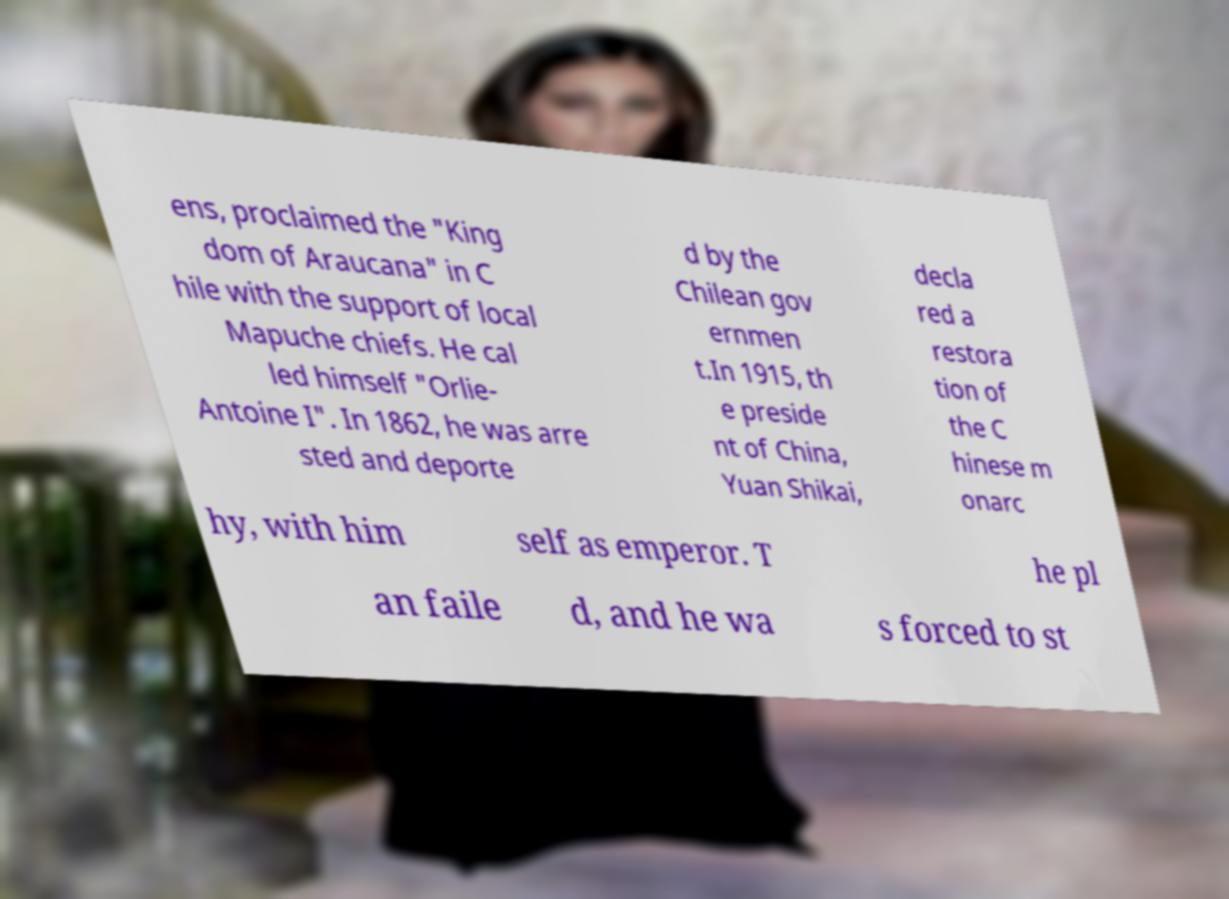Please identify and transcribe the text found in this image. ens, proclaimed the "King dom of Araucana" in C hile with the support of local Mapuche chiefs. He cal led himself "Orlie- Antoine I". In 1862, he was arre sted and deporte d by the Chilean gov ernmen t.In 1915, th e preside nt of China, Yuan Shikai, decla red a restora tion of the C hinese m onarc hy, with him self as emperor. T he pl an faile d, and he wa s forced to st 